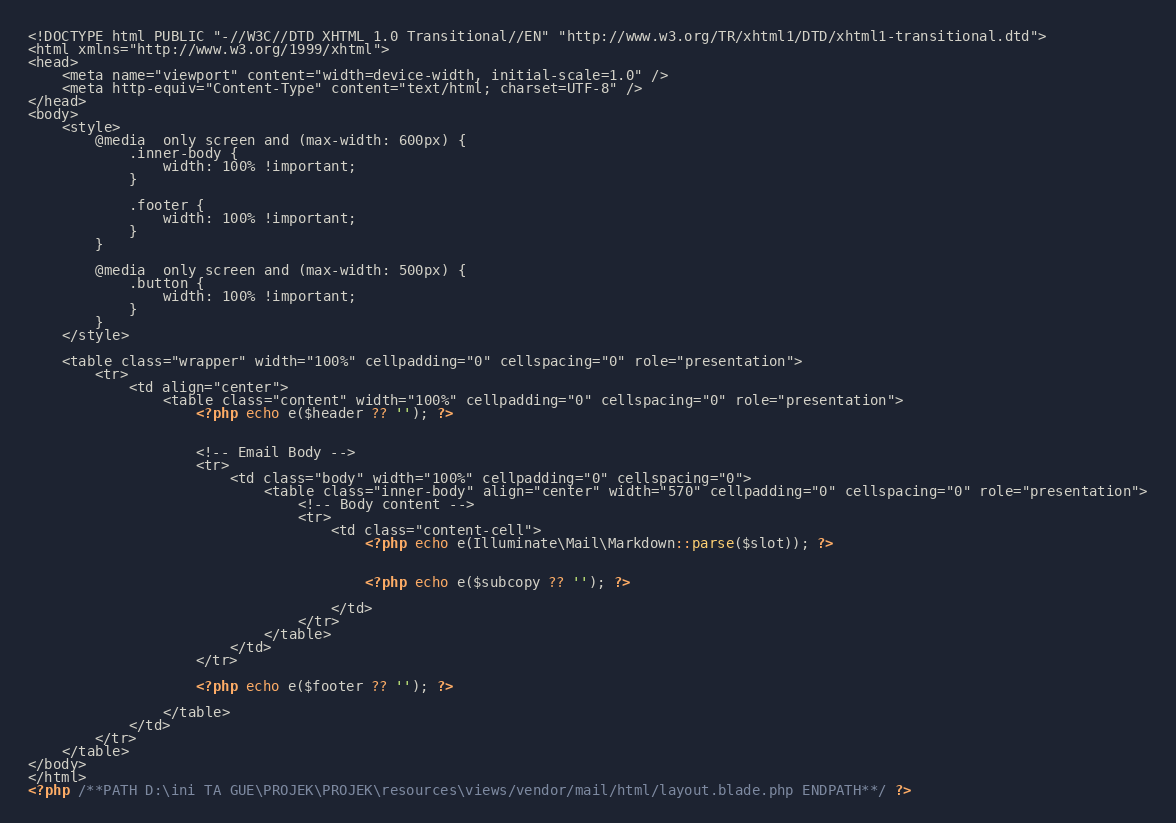Convert code to text. <code><loc_0><loc_0><loc_500><loc_500><_PHP_><!DOCTYPE html PUBLIC "-//W3C//DTD XHTML 1.0 Transitional//EN" "http://www.w3.org/TR/xhtml1/DTD/xhtml1-transitional.dtd">
<html xmlns="http://www.w3.org/1999/xhtml">
<head>
    <meta name="viewport" content="width=device-width, initial-scale=1.0" />
    <meta http-equiv="Content-Type" content="text/html; charset=UTF-8" />
</head>
<body>
    <style>
        @media  only screen and (max-width: 600px) {
            .inner-body {
                width: 100% !important;
            }

            .footer {
                width: 100% !important;
            }
        }

        @media  only screen and (max-width: 500px) {
            .button {
                width: 100% !important;
            }
        }
    </style>

    <table class="wrapper" width="100%" cellpadding="0" cellspacing="0" role="presentation">
        <tr>
            <td align="center">
                <table class="content" width="100%" cellpadding="0" cellspacing="0" role="presentation">
                    <?php echo e($header ?? ''); ?>


                    <!-- Email Body -->
                    <tr>
                        <td class="body" width="100%" cellpadding="0" cellspacing="0">
                            <table class="inner-body" align="center" width="570" cellpadding="0" cellspacing="0" role="presentation">
                                <!-- Body content -->
                                <tr>
                                    <td class="content-cell">
                                        <?php echo e(Illuminate\Mail\Markdown::parse($slot)); ?>


                                        <?php echo e($subcopy ?? ''); ?>

                                    </td>
                                </tr>
                            </table>
                        </td>
                    </tr>

                    <?php echo e($footer ?? ''); ?>

                </table>
            </td>
        </tr>
    </table>
</body>
</html>
<?php /**PATH D:\ini TA GUE\PROJEK\PROJEK\resources\views/vendor/mail/html/layout.blade.php ENDPATH**/ ?></code> 